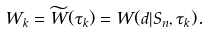<formula> <loc_0><loc_0><loc_500><loc_500>W _ { k } = \widetilde { W } ( \tau _ { k } ) = W ( d | S _ { n } , \tau _ { k } ) .</formula> 